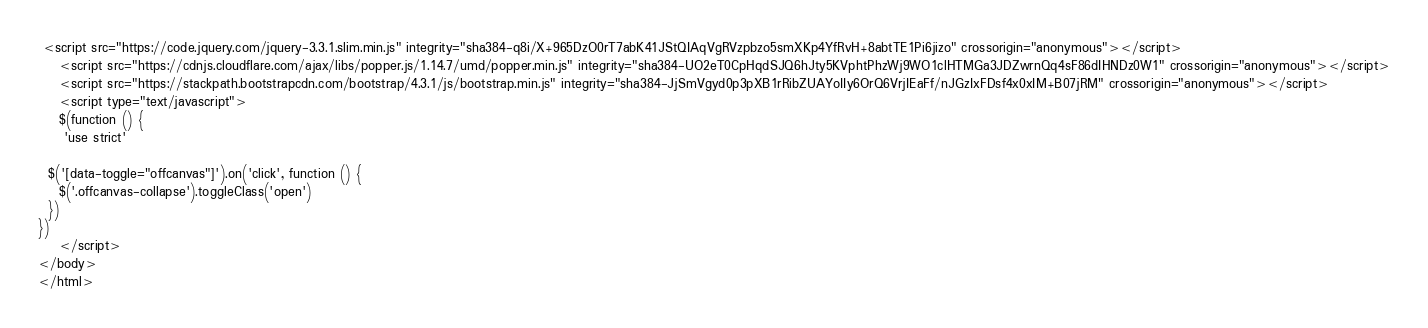<code> <loc_0><loc_0><loc_500><loc_500><_PHP_> <script src="https://code.jquery.com/jquery-3.3.1.slim.min.js" integrity="sha384-q8i/X+965DzO0rT7abK41JStQIAqVgRVzpbzo5smXKp4YfRvH+8abtTE1Pi6jizo" crossorigin="anonymous"></script>
    <script src="https://cdnjs.cloudflare.com/ajax/libs/popper.js/1.14.7/umd/popper.min.js" integrity="sha384-UO2eT0CpHqdSJQ6hJty5KVphtPhzWj9WO1clHTMGa3JDZwrnQq4sF86dIHNDz0W1" crossorigin="anonymous"></script>
    <script src="https://stackpath.bootstrapcdn.com/bootstrap/4.3.1/js/bootstrap.min.js" integrity="sha384-JjSmVgyd0p3pXB1rRibZUAYoIIy6OrQ6VrjIEaFf/nJGzIxFDsf4x0xIM+B07jRM" crossorigin="anonymous"></script>
    <script type="text/javascript">
    $(function () {
     'use strict'

  $('[data-toggle="offcanvas"]').on('click', function () {
    $('.offcanvas-collapse').toggleClass('open')
  })
})
    </script>
</body>
</html></code> 